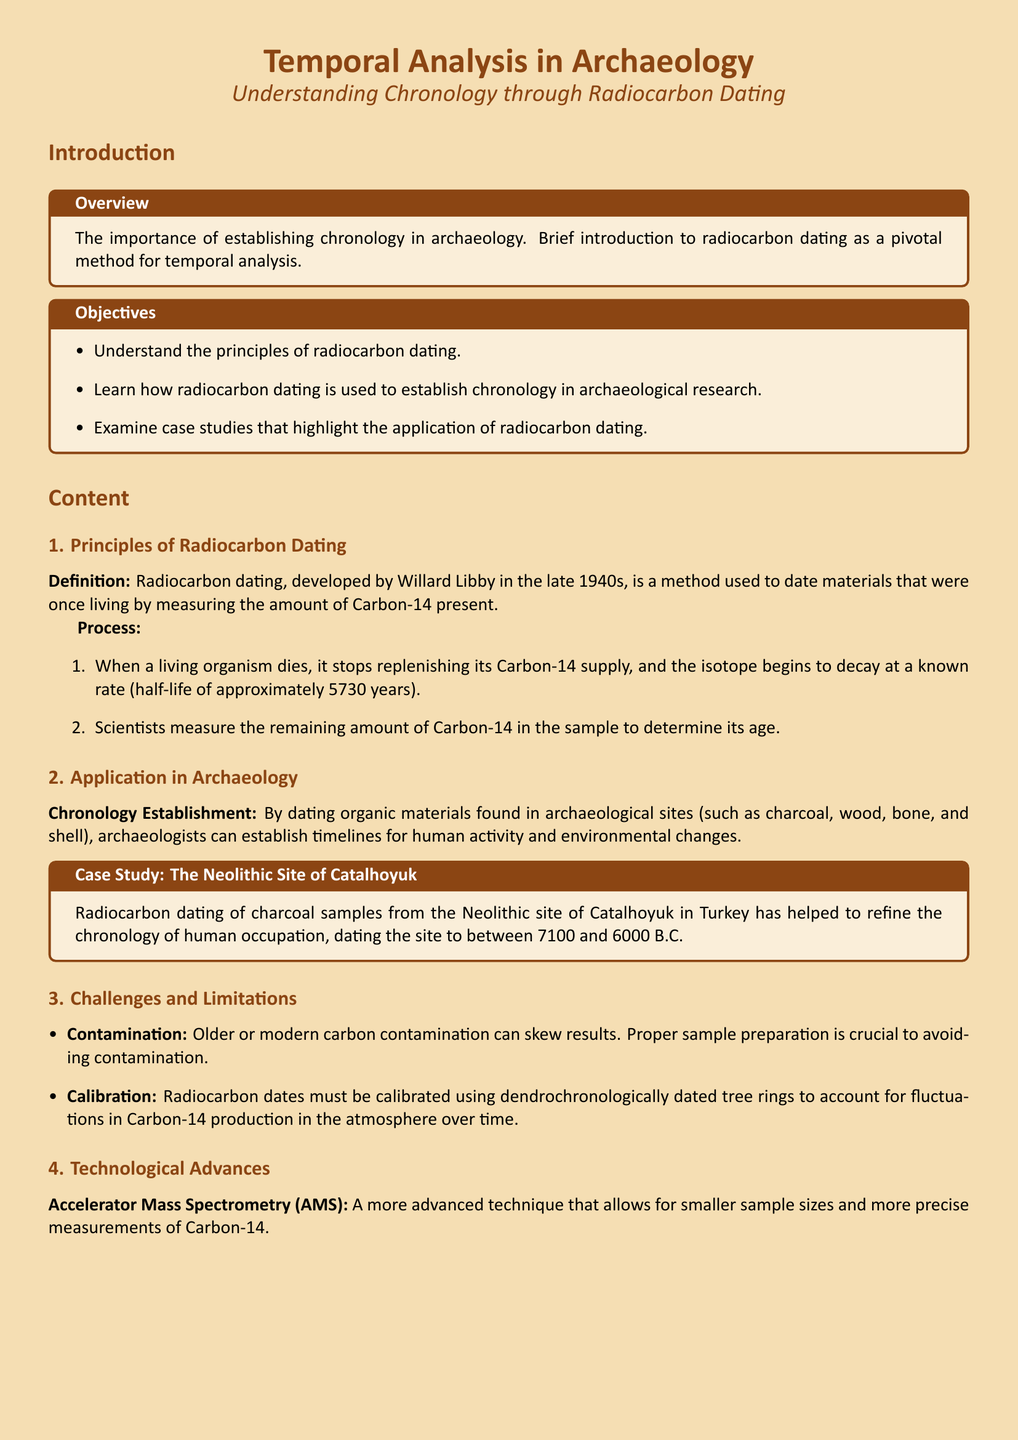What is the main topic of the document? The title indicates the main topic, which is focused on temporal analysis in archaeology.
Answer: Temporal Analysis in Archaeology Who developed radiocarbon dating? The document attributes the development of radiocarbon dating to Willard Libby.
Answer: Willard Libby What is the half-life of Carbon-14? The document states the half-life of Carbon-14 is approximately 5730 years.
Answer: 5730 years Which site is used as a case study? The document mentions the Neolithic site of Catalhoyuk as a case study for radiocarbon dating application.
Answer: Catalhoyuk What is one challenge mentioned regarding radiocarbon dating? The document lists contamination as one of the challenges affecting radiocarbon dating results.
Answer: Contamination What advanced technique is mentioned for radiocarbon dating? Accelerator Mass Spectrometry (AMS) is noted as a more advanced technique for radiocarbon dating.
Answer: Accelerator Mass Spectrometry What years does the dating of Catalhoyuk range from? The document specifies the dating of Catalhoyuk ranges from 7100 to 6000 B.C.
Answer: 7100 to 6000 B.C What is one future direction mentioned for radiocarbon dating? The document highlights continued improvement in calibration techniques as a future direction.
Answer: Improved calibration techniques 